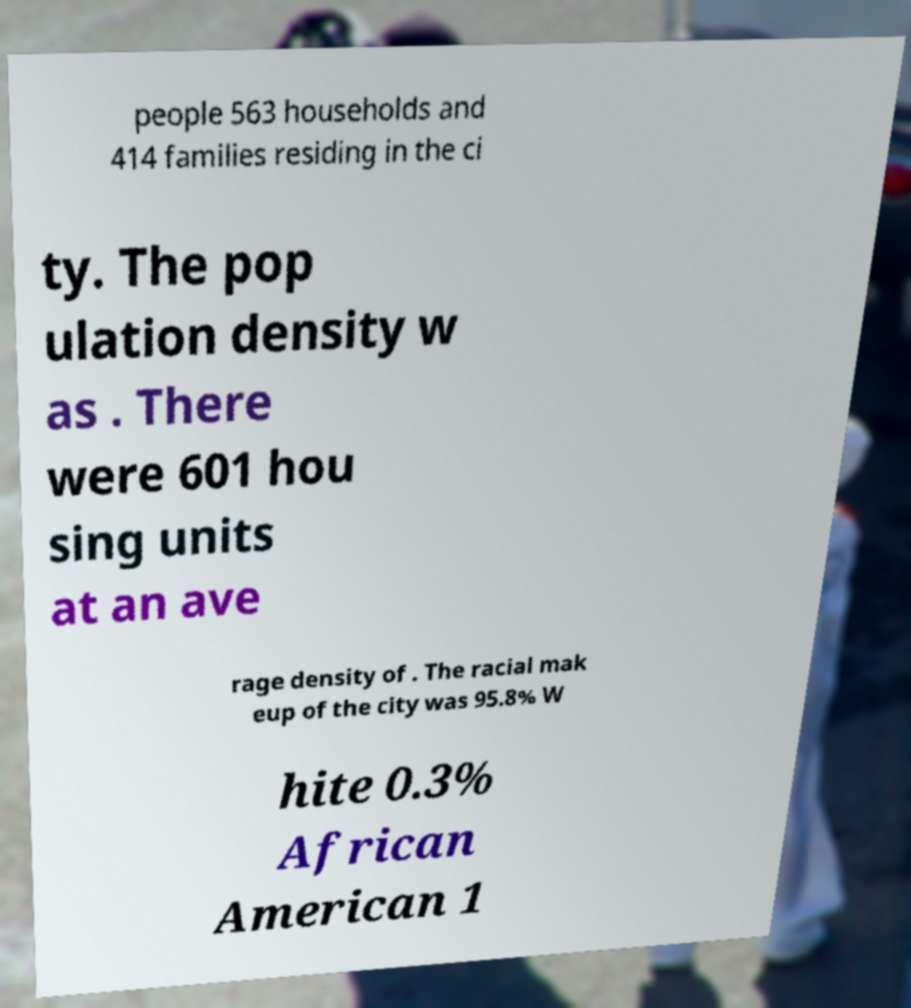I need the written content from this picture converted into text. Can you do that? people 563 households and 414 families residing in the ci ty. The pop ulation density w as . There were 601 hou sing units at an ave rage density of . The racial mak eup of the city was 95.8% W hite 0.3% African American 1 